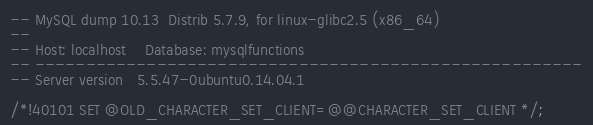Convert code to text. <code><loc_0><loc_0><loc_500><loc_500><_SQL_>-- MySQL dump 10.13  Distrib 5.7.9, for linux-glibc2.5 (x86_64)
--
-- Host: localhost    Database: mysqlfunctions
-- ------------------------------------------------------
-- Server version	5.5.47-0ubuntu0.14.04.1

/*!40101 SET @OLD_CHARACTER_SET_CLIENT=@@CHARACTER_SET_CLIENT */;</code> 